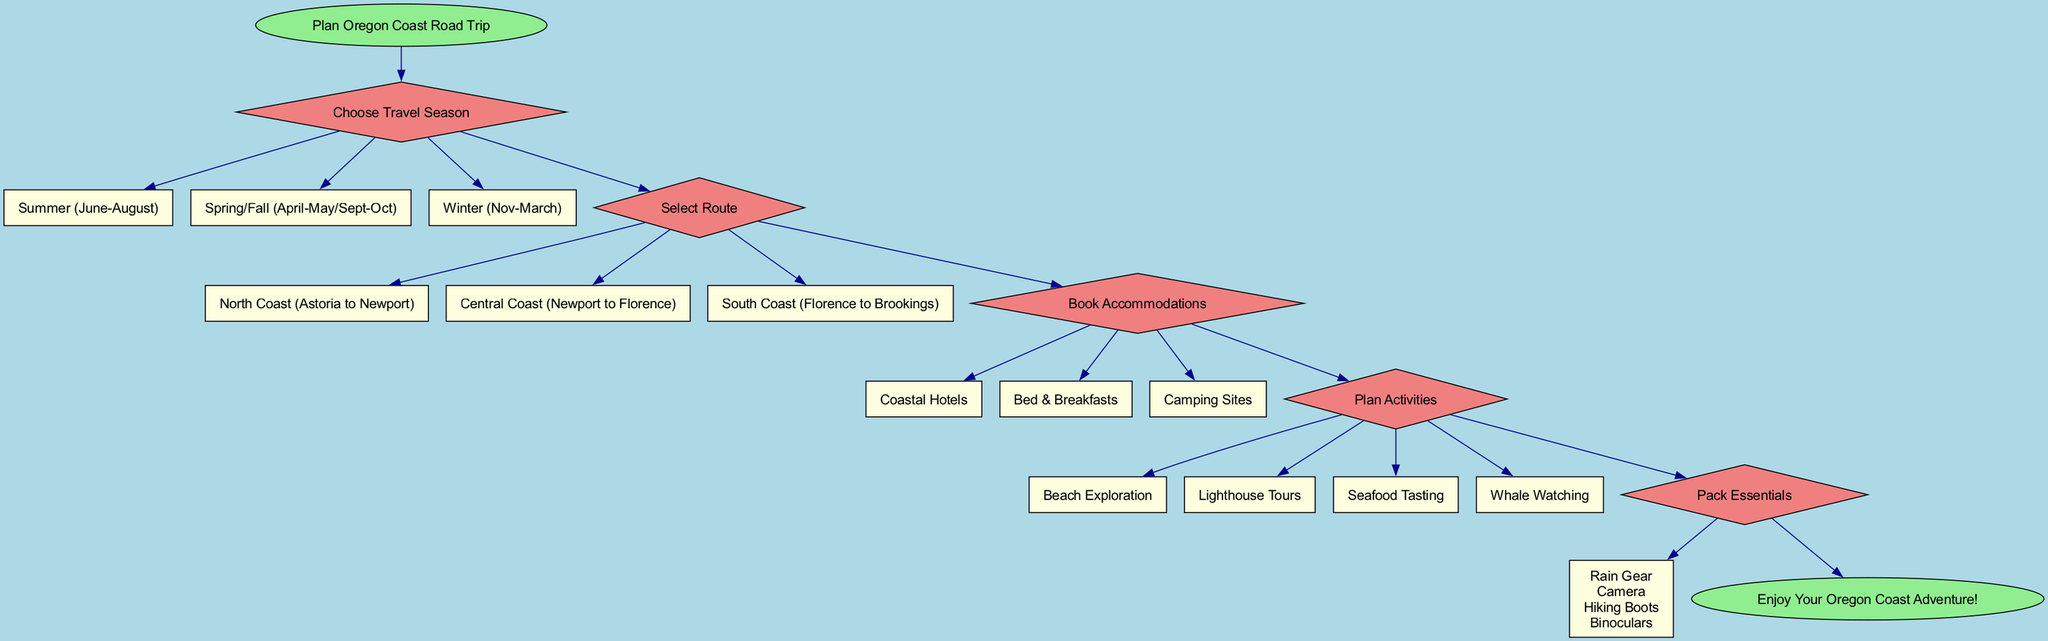What is the first step in planning the road trip? The diagram indicates that the first step is "Choose Travel Season". This is the first decision point shown immediately after the start node.
Answer: Choose Travel Season How many route options are available? The diagram displays three route options that can be selected after "Select Route": North Coast, Central Coast, and South Coast. Counting these options gives a total of three.
Answer: 3 What types of accommodations can be booked? The diagram lists three types of accommodations under "Book Accommodations": Coastal Hotels, Bed & Breakfasts, and Camping Sites. These options are directly linked from that step.
Answer: Coastal Hotels, Bed & Breakfasts, Camping Sites Which activities are included in the planning step? Under "Plan Activities", the diagram provides four activities: Beach Exploration, Lighthouse Tours, Seafood Tasting, and Whale Watching. These are specifically outlined as options connecting from this step.
Answer: Beach Exploration, Lighthouse Tours, Seafood Tasting, Whale Watching What is the last node in the flow chart? The final node in the diagram after all steps is labeled "Enjoy Your Oregon Coast Adventure!" This indicates the completion of the planning process.
Answer: Enjoy Your Oregon Coast Adventure! What is required after choosing a travel season and before selecting a route? After choosing a travel season, the next step is directly related to "Select Route". There is no step between these two in the diagram, allowing the traveler to continue planning without additional steps.
Answer: Select Route What items are included in the packing essentials? The diagram specifies four items under "Pack Essentials": Rain Gear, Camera, Hiking Boots, and Binoculars. These items are consolidated as a list under this step.
Answer: Rain Gear, Camera, Hiking Boots, Binoculars If you choose Summer, what step comes next? If you choose Summer under "Choose Travel Season", the diagram guides you to the next decision step, which is "Select Route", indicating that the traveler continues to plan without interruption.
Answer: Select Route 